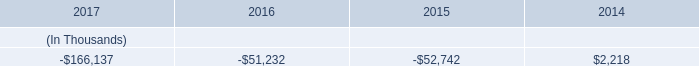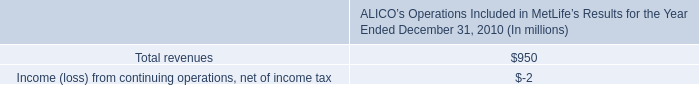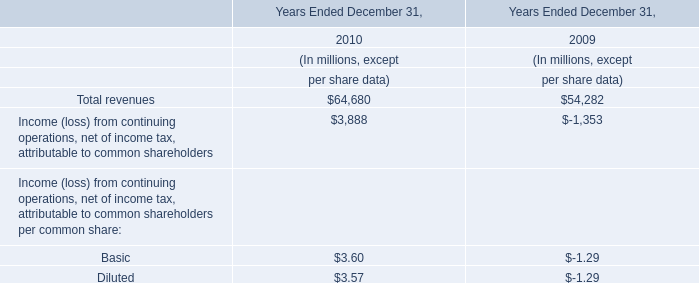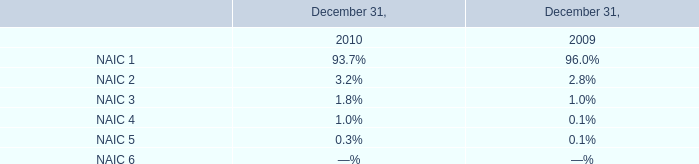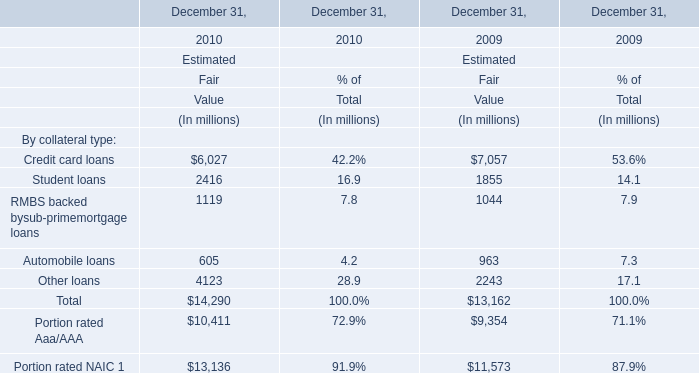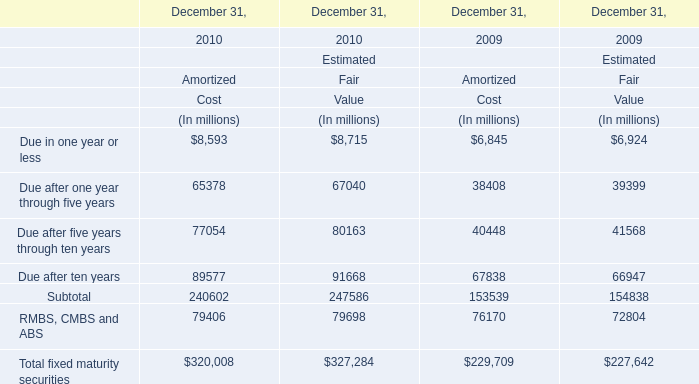In the year with lowest amount of Portion rated NAIC , what's the increasing rate of RMBS backed bysub-primemortgage loans ? 
Computations: ((1119 - 1044) / 1044)
Answer: 0.07184. 